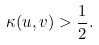Convert formula to latex. <formula><loc_0><loc_0><loc_500><loc_500>\kappa ( u , v ) > \frac { 1 } { 2 } .</formula> 